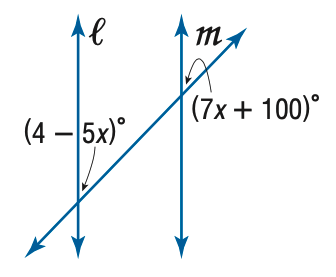Answer the mathemtical geometry problem and directly provide the correct option letter.
Question: Find x so that m \parallel n.
Choices: A: - 8 B: 8 C: 8.67 D: 48 A 